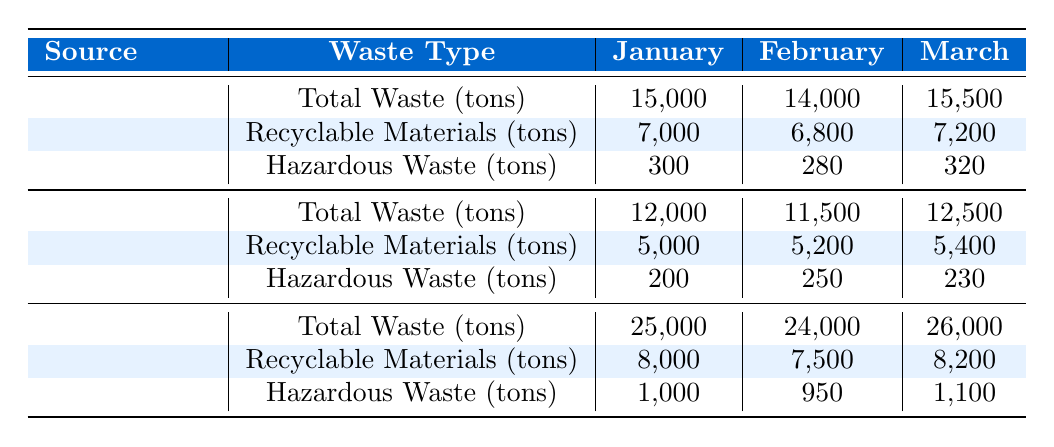What was the total waste generated by the industrial sector in January? The table shows that the total waste generated by the industrial sector in January is listed under the column for January in the Total Waste row. It states 25,000 tons.
Answer: 25,000 tons How much recyclable material was collected from the residential sector in February? Referring to the table, the recyclable materials for the residential sector in February are found in the respective row and column. It shows 6,800 tons.
Answer: 6,800 tons Was the total waste from the commercial sector higher in March than in January? The total waste for the commercial sector in January is 12,000 tons, while in March it is 12,500 tons. Since 12,500 is greater than 12,000, the answer is yes.
Answer: Yes What is the difference in hazardous waste generated between residential and industrial sectors in March? For March, the hazardous waste generated from the residential sector is 320 tons, while from the industrial sector it is 1,100 tons. Subtracting these gives 1,100 - 320 = 780 tons.
Answer: 780 tons What is the average total waste generated by all sources across the three months? The total waste for each source type over the months is: Residential (15,000 + 14,000 + 15,500) = 44,500 tons, Commercial (12,000 + 11,500 + 12,500) = 36,000 tons, Industrial (25,000 + 24,000 + 26,000) = 75,000 tons. The sum of these is 44,500 + 36,000 + 75,000 = 155,500 tons. There are 9 months, so the average is 155,500 / 9 ≈ 17,278 tons.
Answer: 17,278 tons In which month did the industrial sector generate the highest amount of hazardous waste? Looking at the hazardous waste figures for the industrial sector: January (1,000 tons), February (950 tons), and March (1,100 tons), we see that March has the highest amount at 1,100 tons.
Answer: March 